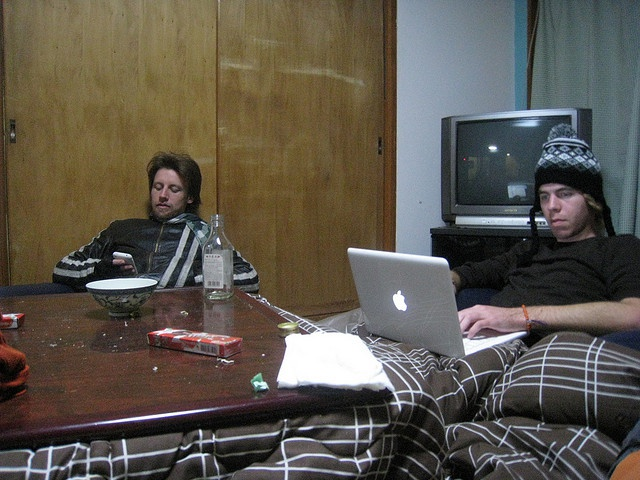Describe the objects in this image and their specific colors. I can see dining table in black, maroon, and white tones, people in black, gray, and darkgray tones, tv in black, darkblue, and gray tones, people in black, gray, and darkgray tones, and laptop in black, gray, and white tones in this image. 